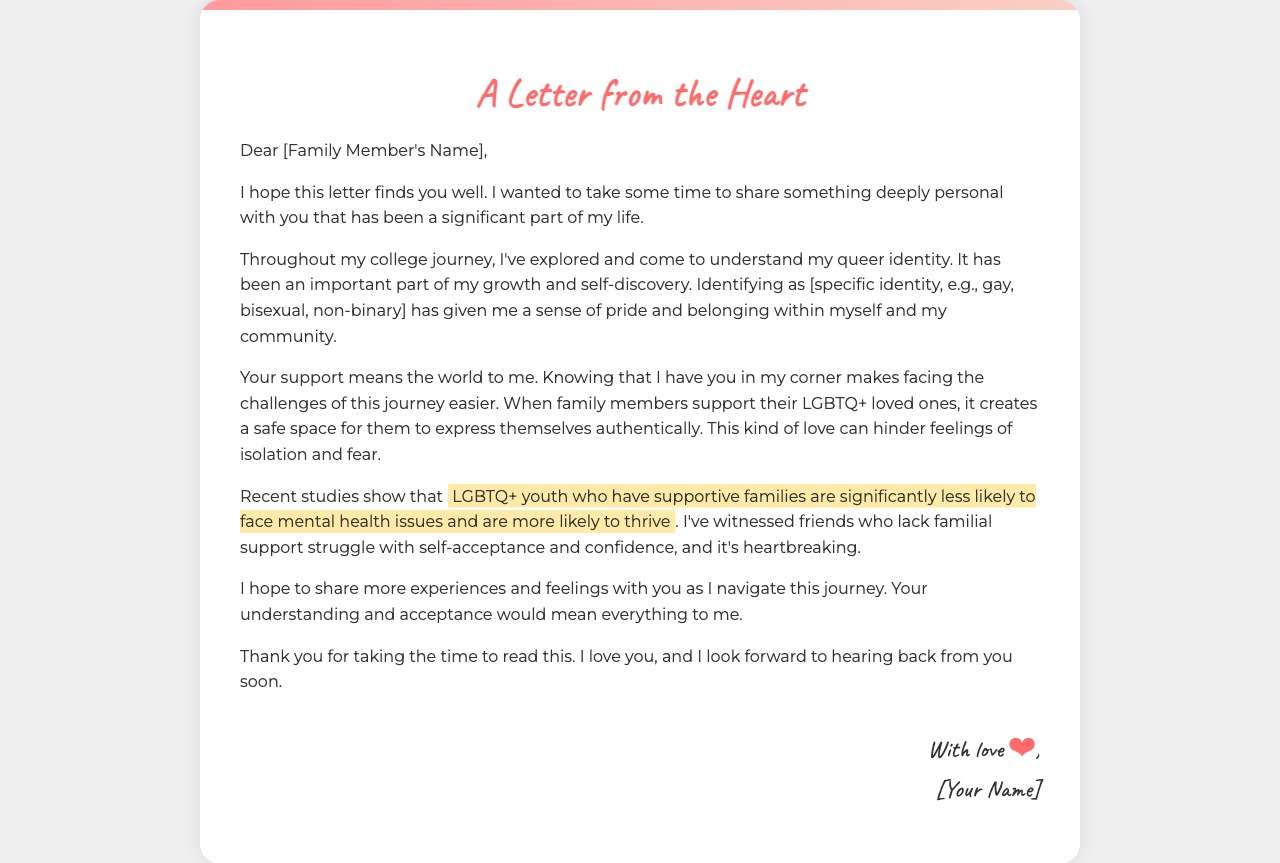What is the title of the letter? The title of the letter is mentioned at the top of the document.
Answer: A Letter from the Heart Who is the letter addressed to? The letter is addressed to a specific family member, as indicated at the beginning of the document.
Answer: [Family Member's Name] What identity does the writer identify as? The document specifies the writer's identity as part of their personal journey.
Answer: [specific identity] What does the writer highlight about LGBTQ+ youth with supportive families? The document includes a specific highlight about the impact of familial support on LGBTQ+ youth.
Answer: significantly less likely to face mental health issues What expression does the writer use to sign off the letter? The writer's signature section indicates how they close the letter.
Answer: With love Why is the writer reaching out to their family member? The writer expresses the main reason for addressing the letter within the text.
Answer: To share their queer identity and seek support What emotional impact does the writer mention regarding lack of family support? The letter discusses a significant emotional effect of not having familial support.
Answer: Heartbreaking What type of studies does the writer refer to in the letter? The document mentions evidence related to LGBTQ+ youth in the text.
Answer: Recent studies 